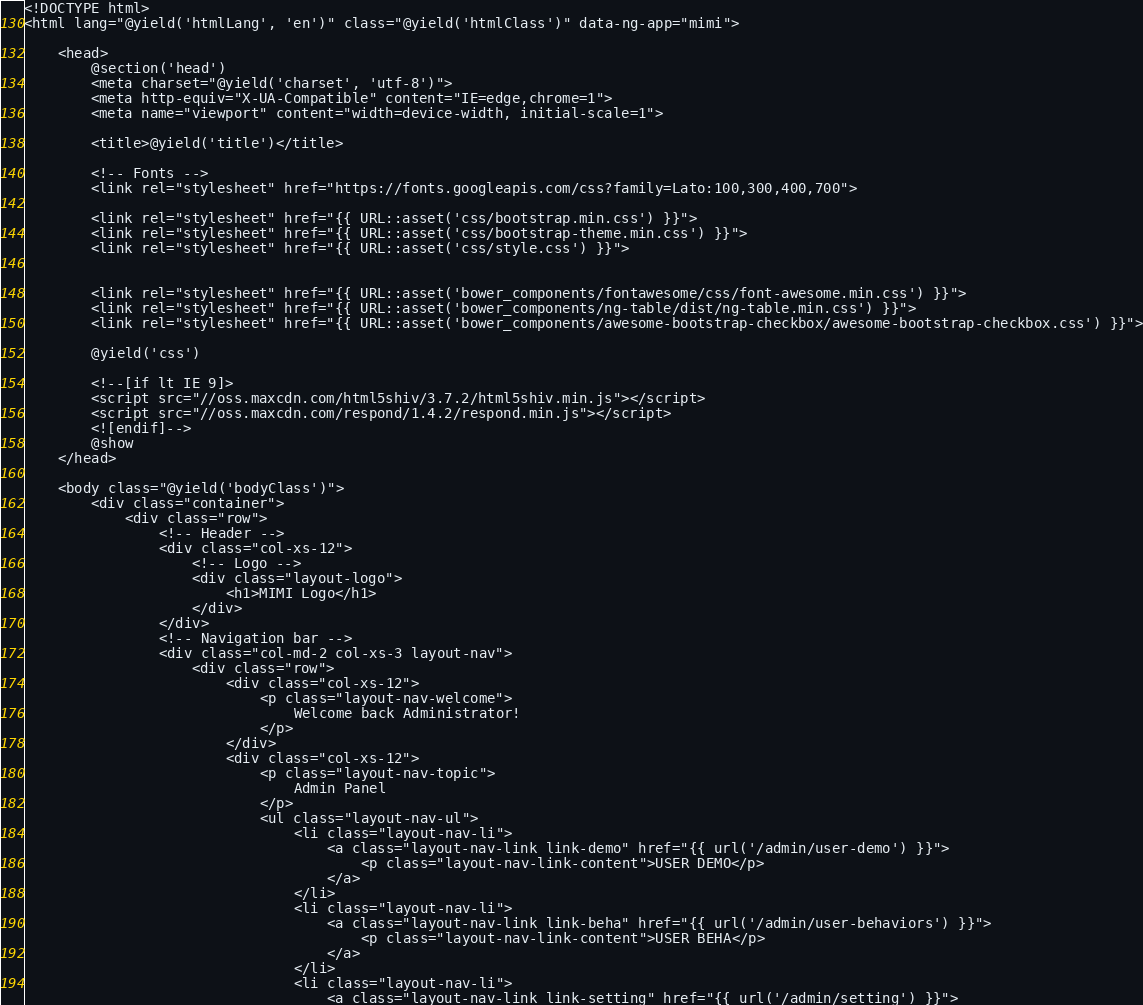Convert code to text. <code><loc_0><loc_0><loc_500><loc_500><_PHP_><!DOCTYPE html>
<html lang="@yield('htmlLang', 'en')" class="@yield('htmlClass')" data-ng-app="mimi">

	<head>
		@section('head')
		<meta charset="@yield('charset', 'utf-8')">
		<meta http-equiv="X-UA-Compatible" content="IE=edge,chrome=1">
		<meta name="viewport" content="width=device-width, initial-scale=1">

		<title>@yield('title')</title>

	    <!-- Fonts -->
	    <link rel="stylesheet" href="https://fonts.googleapis.com/css?family=Lato:100,300,400,700">
		
		<link rel="stylesheet" href="{{ URL::asset('css/bootstrap.min.css') }}">
		<link rel="stylesheet" href="{{ URL::asset('css/bootstrap-theme.min.css') }}">
		<link rel="stylesheet" href="{{ URL::asset('css/style.css') }}">


		<link rel="stylesheet" href="{{ URL::asset('bower_components/fontawesome/css/font-awesome.min.css') }}">
		<link rel="stylesheet" href="{{ URL::asset('bower_components/ng-table/dist/ng-table.min.css') }}">
		<link rel="stylesheet" href="{{ URL::asset('bower_components/awesome-bootstrap-checkbox/awesome-bootstrap-checkbox.css') }}">

		@yield('css')
		
		<!--[if lt IE 9]>
		<script src="//oss.maxcdn.com/html5shiv/3.7.2/html5shiv.min.js"></script>
		<script src="//oss.maxcdn.com/respond/1.4.2/respond.min.js"></script>
		<![endif]-->
		@show
	</head>

	<body class="@yield('bodyClass')">
		<div class="container">
			<div class="row">
				<!-- Header -->
				<div class="col-xs-12">
					<!-- Logo -->
					<div class="layout-logo">
						<h1>MIMI Logo</h1>
					</div>
				</div>
				<!-- Navigation bar -->
				<div class="col-md-2 col-xs-3 layout-nav">
					<div class="row">
						<div class="col-xs-12">
							<p class="layout-nav-welcome">
								Welcome back Administrator!
							</p>
						</div>
						<div class="col-xs-12">
							<p class="layout-nav-topic">
								Admin Panel
							</p>
							<ul class="layout-nav-ul">
								<li class="layout-nav-li">
									<a class="layout-nav-link link-demo" href="{{ url('/admin/user-demo') }}">
										<p class="layout-nav-link-content">USER DEMO</p>
									</a>
								</li>
								<li class="layout-nav-li">
									<a class="layout-nav-link link-beha" href="{{ url('/admin/user-behaviors') }}">
										<p class="layout-nav-link-content">USER BEHA</p>
									</a>
								</li>
								<li class="layout-nav-li">
									<a class="layout-nav-link link-setting" href="{{ url('/admin/setting') }}"></code> 